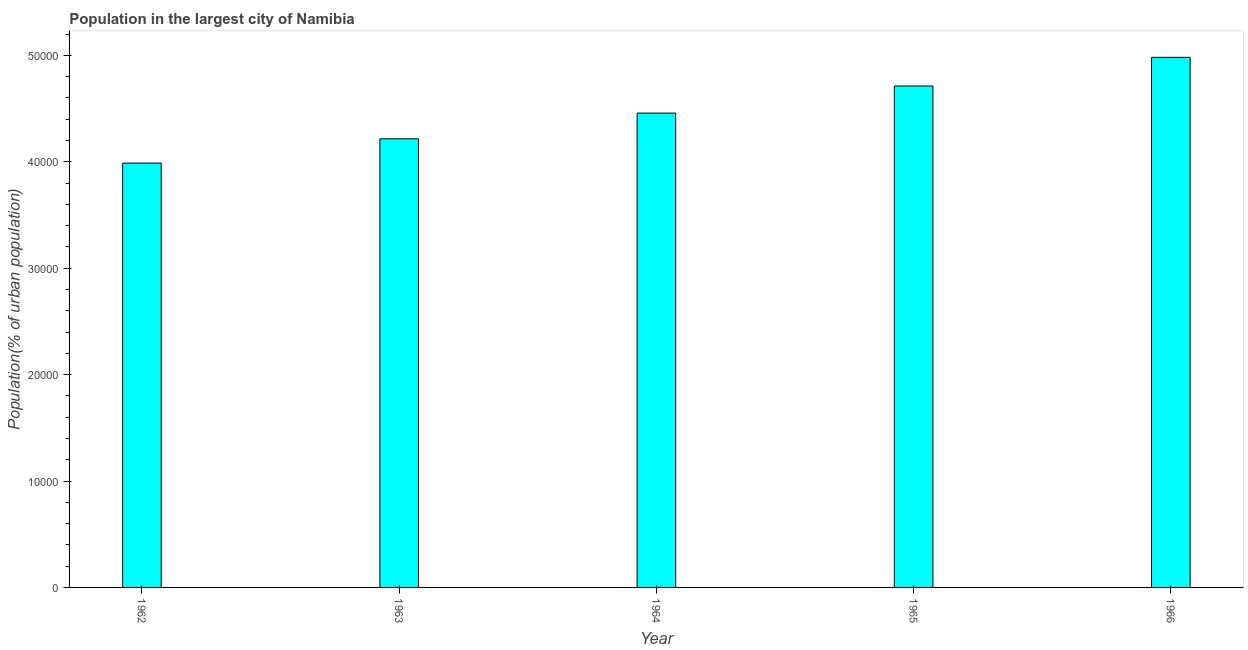What is the title of the graph?
Make the answer very short. Population in the largest city of Namibia. What is the label or title of the Y-axis?
Your response must be concise. Population(% of urban population). What is the population in largest city in 1965?
Your answer should be compact. 4.71e+04. Across all years, what is the maximum population in largest city?
Offer a terse response. 4.98e+04. Across all years, what is the minimum population in largest city?
Provide a short and direct response. 3.99e+04. In which year was the population in largest city maximum?
Make the answer very short. 1966. What is the sum of the population in largest city?
Give a very brief answer. 2.24e+05. What is the difference between the population in largest city in 1965 and 1966?
Give a very brief answer. -2696. What is the average population in largest city per year?
Offer a very short reply. 4.47e+04. What is the median population in largest city?
Your answer should be compact. 4.46e+04. In how many years, is the population in largest city greater than 10000 %?
Keep it short and to the point. 5. Do a majority of the years between 1964 and 1966 (inclusive) have population in largest city greater than 50000 %?
Offer a very short reply. No. What is the ratio of the population in largest city in 1962 to that in 1966?
Offer a terse response. 0.8. Is the difference between the population in largest city in 1963 and 1965 greater than the difference between any two years?
Offer a terse response. No. What is the difference between the highest and the second highest population in largest city?
Your answer should be very brief. 2696. Is the sum of the population in largest city in 1965 and 1966 greater than the maximum population in largest city across all years?
Provide a succinct answer. Yes. What is the difference between the highest and the lowest population in largest city?
Ensure brevity in your answer.  9939. In how many years, is the population in largest city greater than the average population in largest city taken over all years?
Ensure brevity in your answer.  2. How many bars are there?
Your response must be concise. 5. How many years are there in the graph?
Keep it short and to the point. 5. What is the Population(% of urban population) of 1962?
Make the answer very short. 3.99e+04. What is the Population(% of urban population) in 1963?
Keep it short and to the point. 4.22e+04. What is the Population(% of urban population) in 1964?
Your answer should be compact. 4.46e+04. What is the Population(% of urban population) in 1965?
Provide a short and direct response. 4.71e+04. What is the Population(% of urban population) of 1966?
Offer a terse response. 4.98e+04. What is the difference between the Population(% of urban population) in 1962 and 1963?
Your answer should be compact. -2281. What is the difference between the Population(% of urban population) in 1962 and 1964?
Offer a very short reply. -4697. What is the difference between the Population(% of urban population) in 1962 and 1965?
Offer a very short reply. -7243. What is the difference between the Population(% of urban population) in 1962 and 1966?
Your response must be concise. -9939. What is the difference between the Population(% of urban population) in 1963 and 1964?
Provide a short and direct response. -2416. What is the difference between the Population(% of urban population) in 1963 and 1965?
Make the answer very short. -4962. What is the difference between the Population(% of urban population) in 1963 and 1966?
Provide a succinct answer. -7658. What is the difference between the Population(% of urban population) in 1964 and 1965?
Your answer should be very brief. -2546. What is the difference between the Population(% of urban population) in 1964 and 1966?
Make the answer very short. -5242. What is the difference between the Population(% of urban population) in 1965 and 1966?
Give a very brief answer. -2696. What is the ratio of the Population(% of urban population) in 1962 to that in 1963?
Provide a succinct answer. 0.95. What is the ratio of the Population(% of urban population) in 1962 to that in 1964?
Your response must be concise. 0.9. What is the ratio of the Population(% of urban population) in 1962 to that in 1965?
Provide a short and direct response. 0.85. What is the ratio of the Population(% of urban population) in 1962 to that in 1966?
Offer a terse response. 0.8. What is the ratio of the Population(% of urban population) in 1963 to that in 1964?
Provide a succinct answer. 0.95. What is the ratio of the Population(% of urban population) in 1963 to that in 1965?
Ensure brevity in your answer.  0.9. What is the ratio of the Population(% of urban population) in 1963 to that in 1966?
Keep it short and to the point. 0.85. What is the ratio of the Population(% of urban population) in 1964 to that in 1965?
Your answer should be compact. 0.95. What is the ratio of the Population(% of urban population) in 1964 to that in 1966?
Make the answer very short. 0.9. What is the ratio of the Population(% of urban population) in 1965 to that in 1966?
Your answer should be very brief. 0.95. 